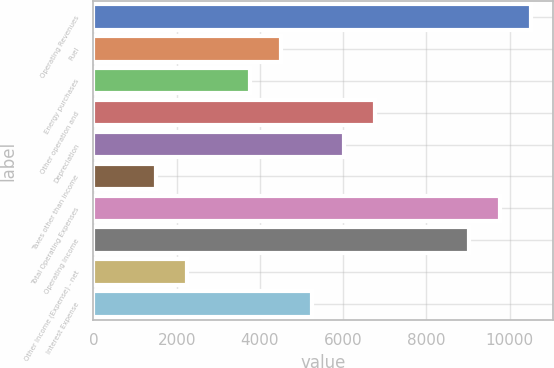Convert chart to OTSL. <chart><loc_0><loc_0><loc_500><loc_500><bar_chart><fcel>Operating Revenues<fcel>Fuel<fcel>Energy purchases<fcel>Other operation and<fcel>Depreciation<fcel>Taxes other than income<fcel>Total Operating Expenses<fcel>Operating Income<fcel>Other Income (Expense) - net<fcel>Interest Expense<nl><fcel>10522.7<fcel>4511.31<fcel>3759.89<fcel>6765.57<fcel>6014.15<fcel>1505.63<fcel>9771.25<fcel>9019.83<fcel>2257.05<fcel>5262.73<nl></chart> 